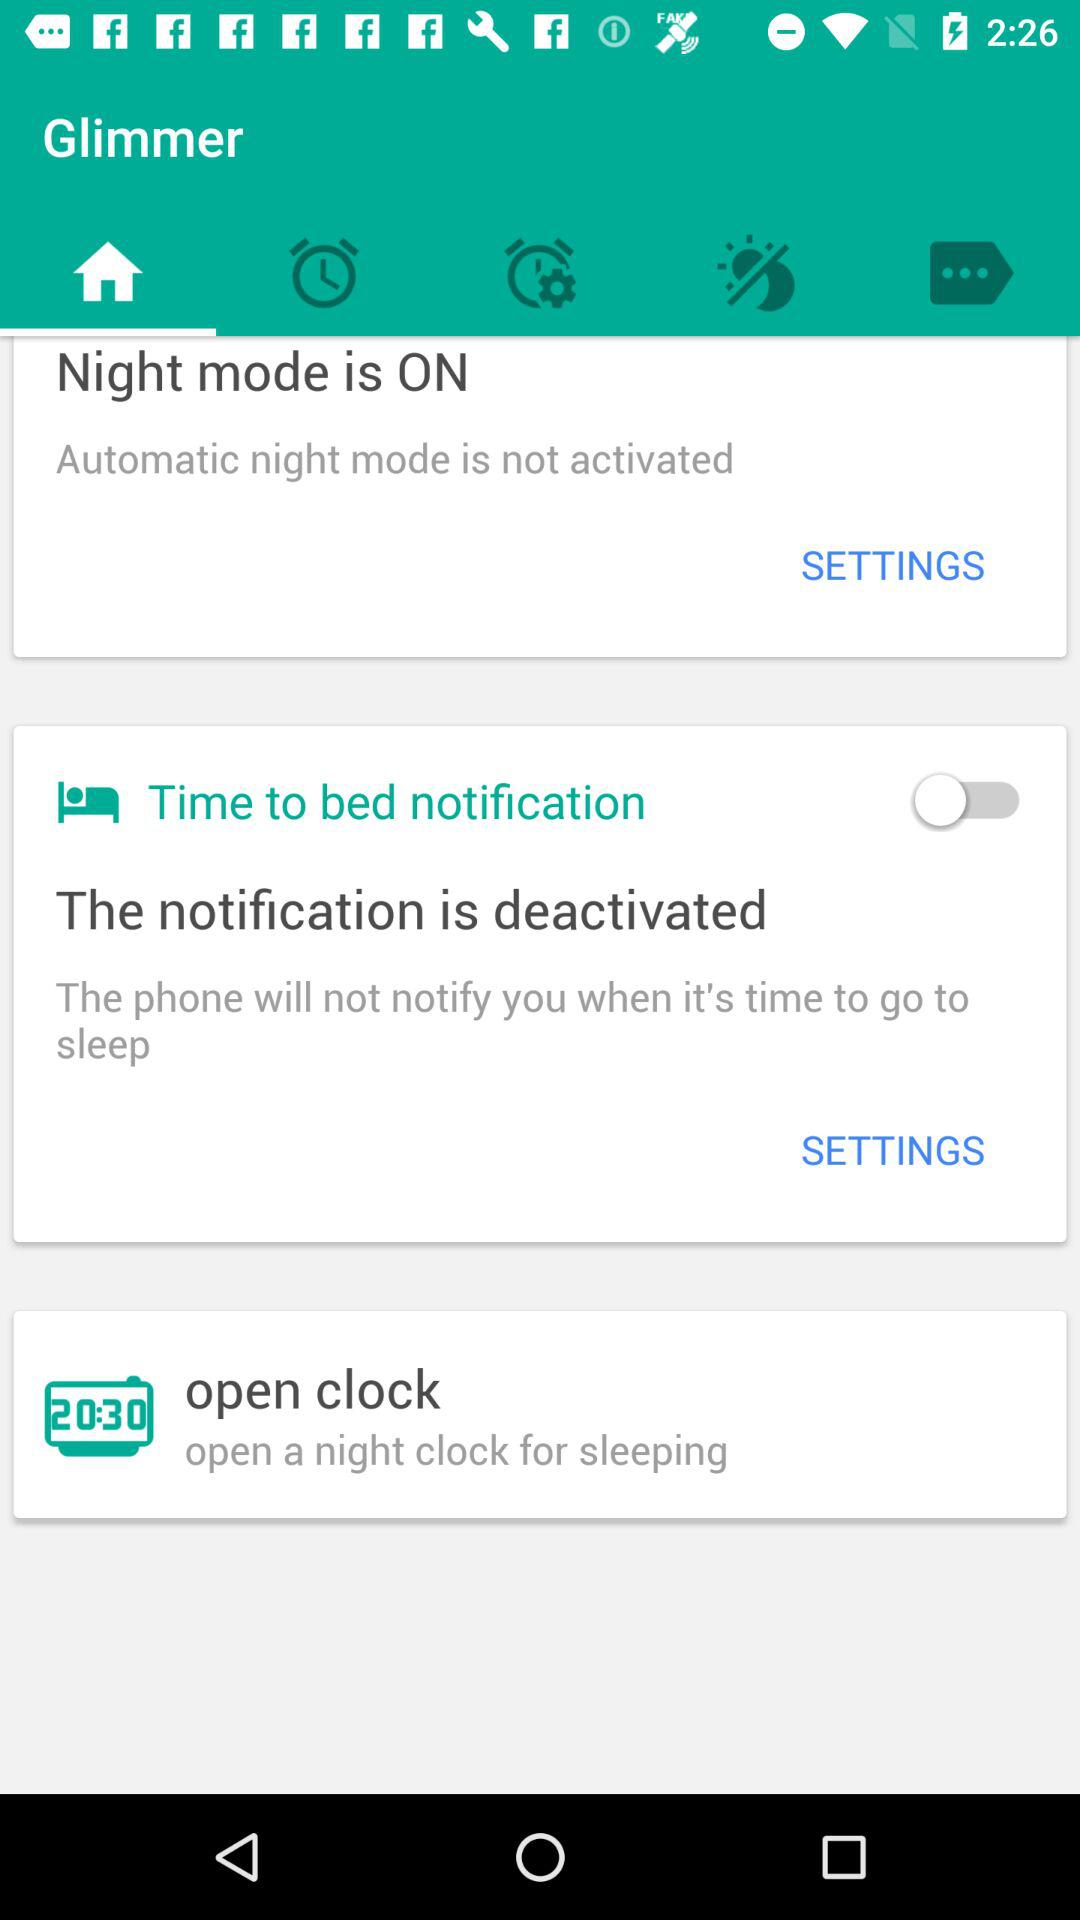How many items are in the settings menu?
Answer the question using a single word or phrase. 3 